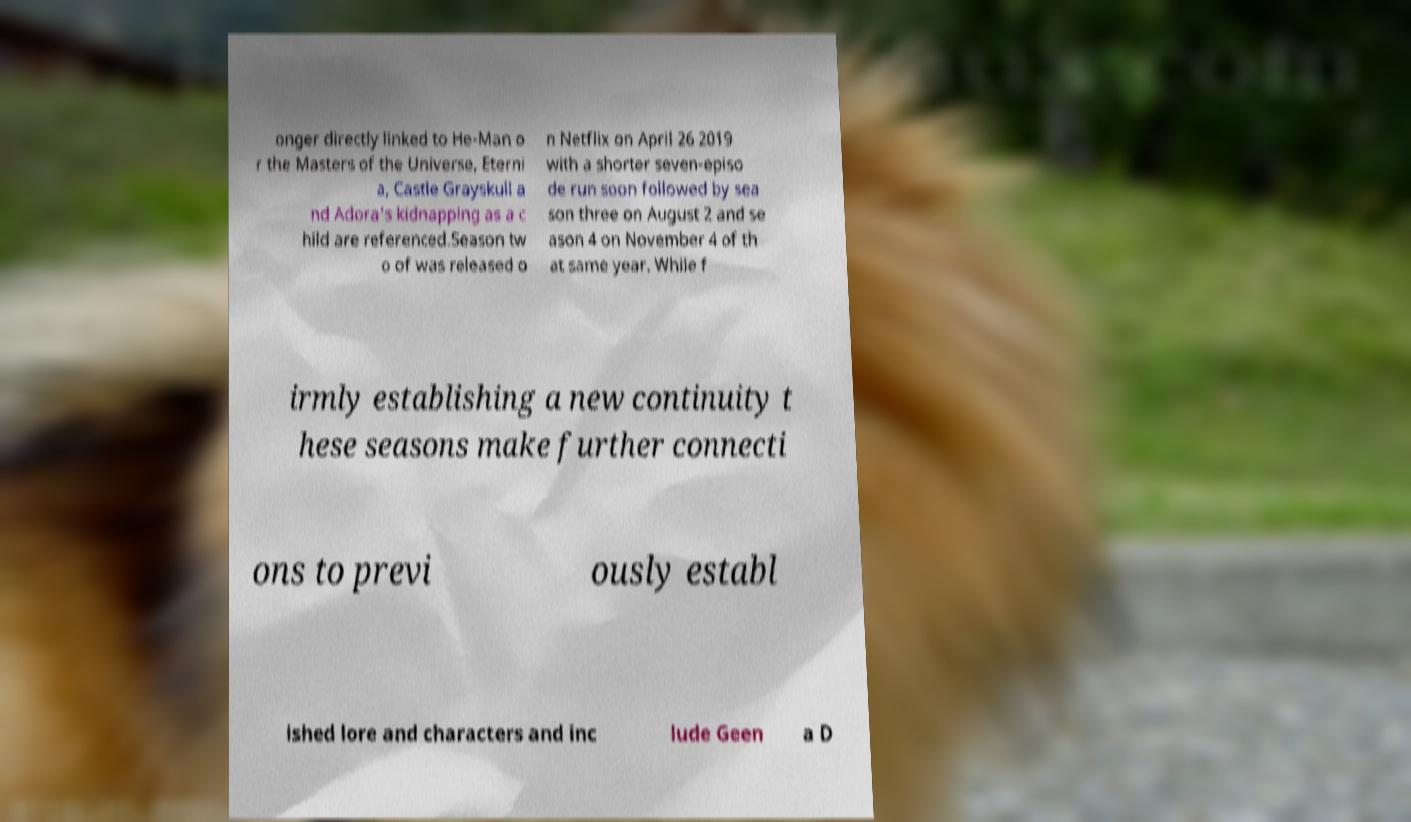I need the written content from this picture converted into text. Can you do that? onger directly linked to He-Man o r the Masters of the Universe, Eterni a, Castle Grayskull a nd Adora's kidnapping as a c hild are referenced.Season tw o of was released o n Netflix on April 26 2019 with a shorter seven-episo de run soon followed by sea son three on August 2 and se ason 4 on November 4 of th at same year. While f irmly establishing a new continuity t hese seasons make further connecti ons to previ ously establ ished lore and characters and inc lude Geen a D 